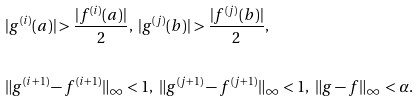<formula> <loc_0><loc_0><loc_500><loc_500>& | g ^ { ( i ) } ( a ) | > \frac { | f ^ { ( i ) } ( a ) | } 2 , \ | g ^ { ( j ) } ( b ) | > \frac { | f ^ { ( j ) } ( b ) | } 2 , \\ \\ & \| g ^ { ( i + 1 ) } - f ^ { ( i + 1 ) } \| _ { \infty } < 1 , \ \| g ^ { ( j + 1 ) } - f ^ { ( j + 1 ) } \| _ { \infty } < 1 , \ \| g - f \| _ { \infty } < \alpha .</formula> 